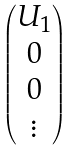<formula> <loc_0><loc_0><loc_500><loc_500>\begin{pmatrix} U _ { 1 } \\ 0 \\ 0 \\ \vdots \end{pmatrix}</formula> 